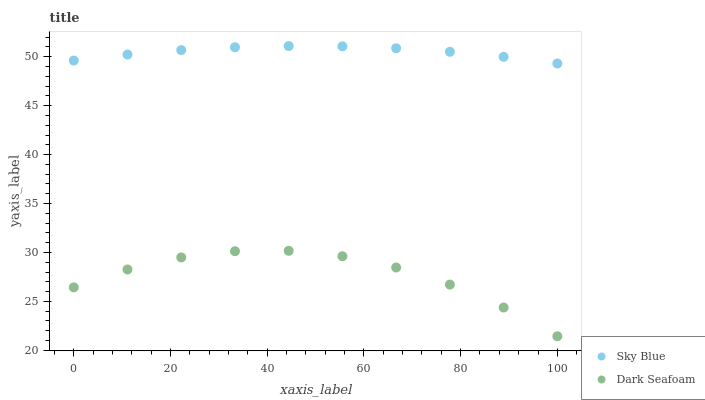Does Dark Seafoam have the minimum area under the curve?
Answer yes or no. Yes. Does Sky Blue have the maximum area under the curve?
Answer yes or no. Yes. Does Dark Seafoam have the maximum area under the curve?
Answer yes or no. No. Is Sky Blue the smoothest?
Answer yes or no. Yes. Is Dark Seafoam the roughest?
Answer yes or no. Yes. Is Dark Seafoam the smoothest?
Answer yes or no. No. Does Dark Seafoam have the lowest value?
Answer yes or no. Yes. Does Sky Blue have the highest value?
Answer yes or no. Yes. Does Dark Seafoam have the highest value?
Answer yes or no. No. Is Dark Seafoam less than Sky Blue?
Answer yes or no. Yes. Is Sky Blue greater than Dark Seafoam?
Answer yes or no. Yes. Does Dark Seafoam intersect Sky Blue?
Answer yes or no. No. 